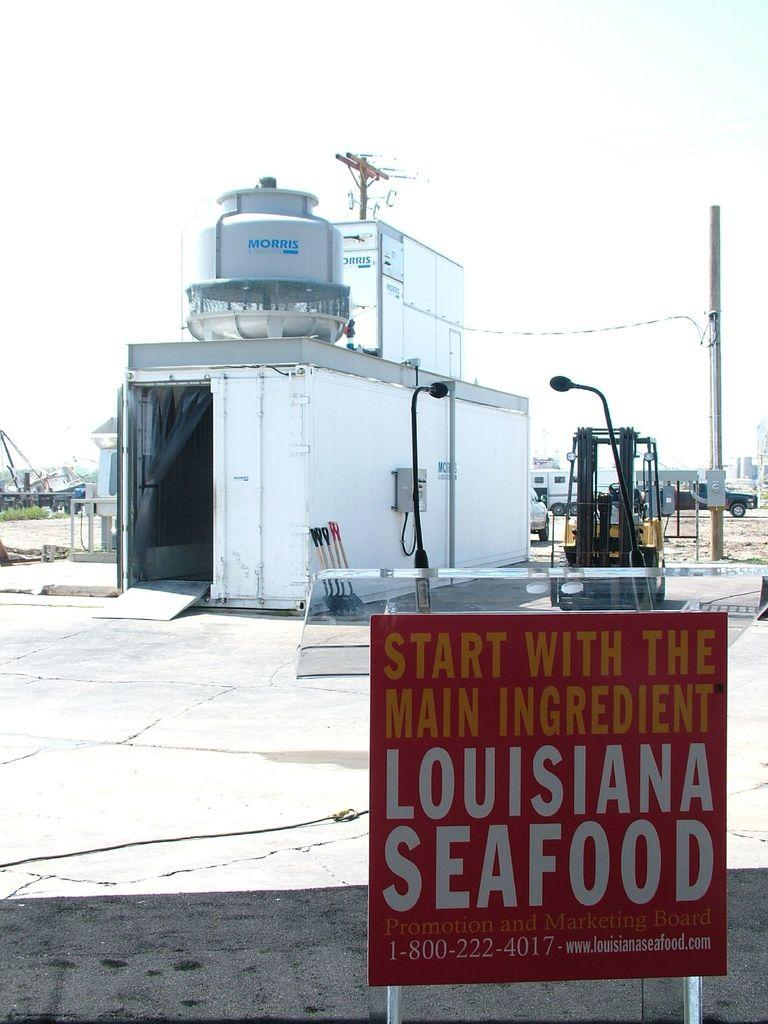<image>
Summarize the visual content of the image. A small red sign advertises the goodness of Louisiana seafood. 